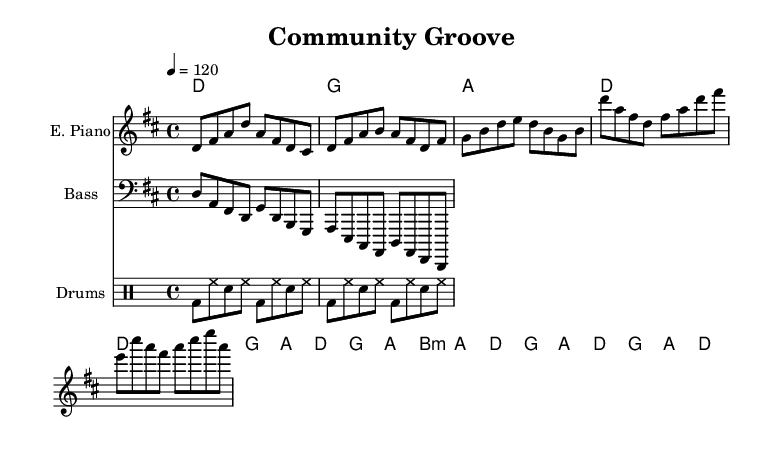What is the key signature of this music? The music is in D major, which has two sharps (F# and C#). This can be identified from the explicit key signature indicated at the beginning of the staff.
Answer: D major What is the time signature? The time signature is 4/4, as indicated in the music notation. This means there are four beats in each measure, and the quarter note gets one beat.
Answer: 4/4 What is the tempo marking given in the music? The tempo marking states "4 = 120," indicating that a quarter note is to be played at 120 beats per minute. This is located at the beginning of the score.
Answer: 120 How many measures does the verse section contain? The verse section is made up of 8 measures as noted when examining the provided electric piano staff and the chord changes during that section.
Answer: 8 Which instrument plays the introductory chord progression? The electric piano plays the introductory chord progression, as noted in the first staff, which outlines the chord changes for the intro.
Answer: Electric piano What musical style does this piece represent? This piece represents the Disco style, characterized by its upbeat tempo, syncopated bass lines, and distinctive drum patterns, which are typical of disco music.
Answer: Disco How many different chord changes are in the chorus section? The chorus section contains 6 distinct chord changes, which can be counted by analyzing the chord symbols above the music for that section.
Answer: 6 